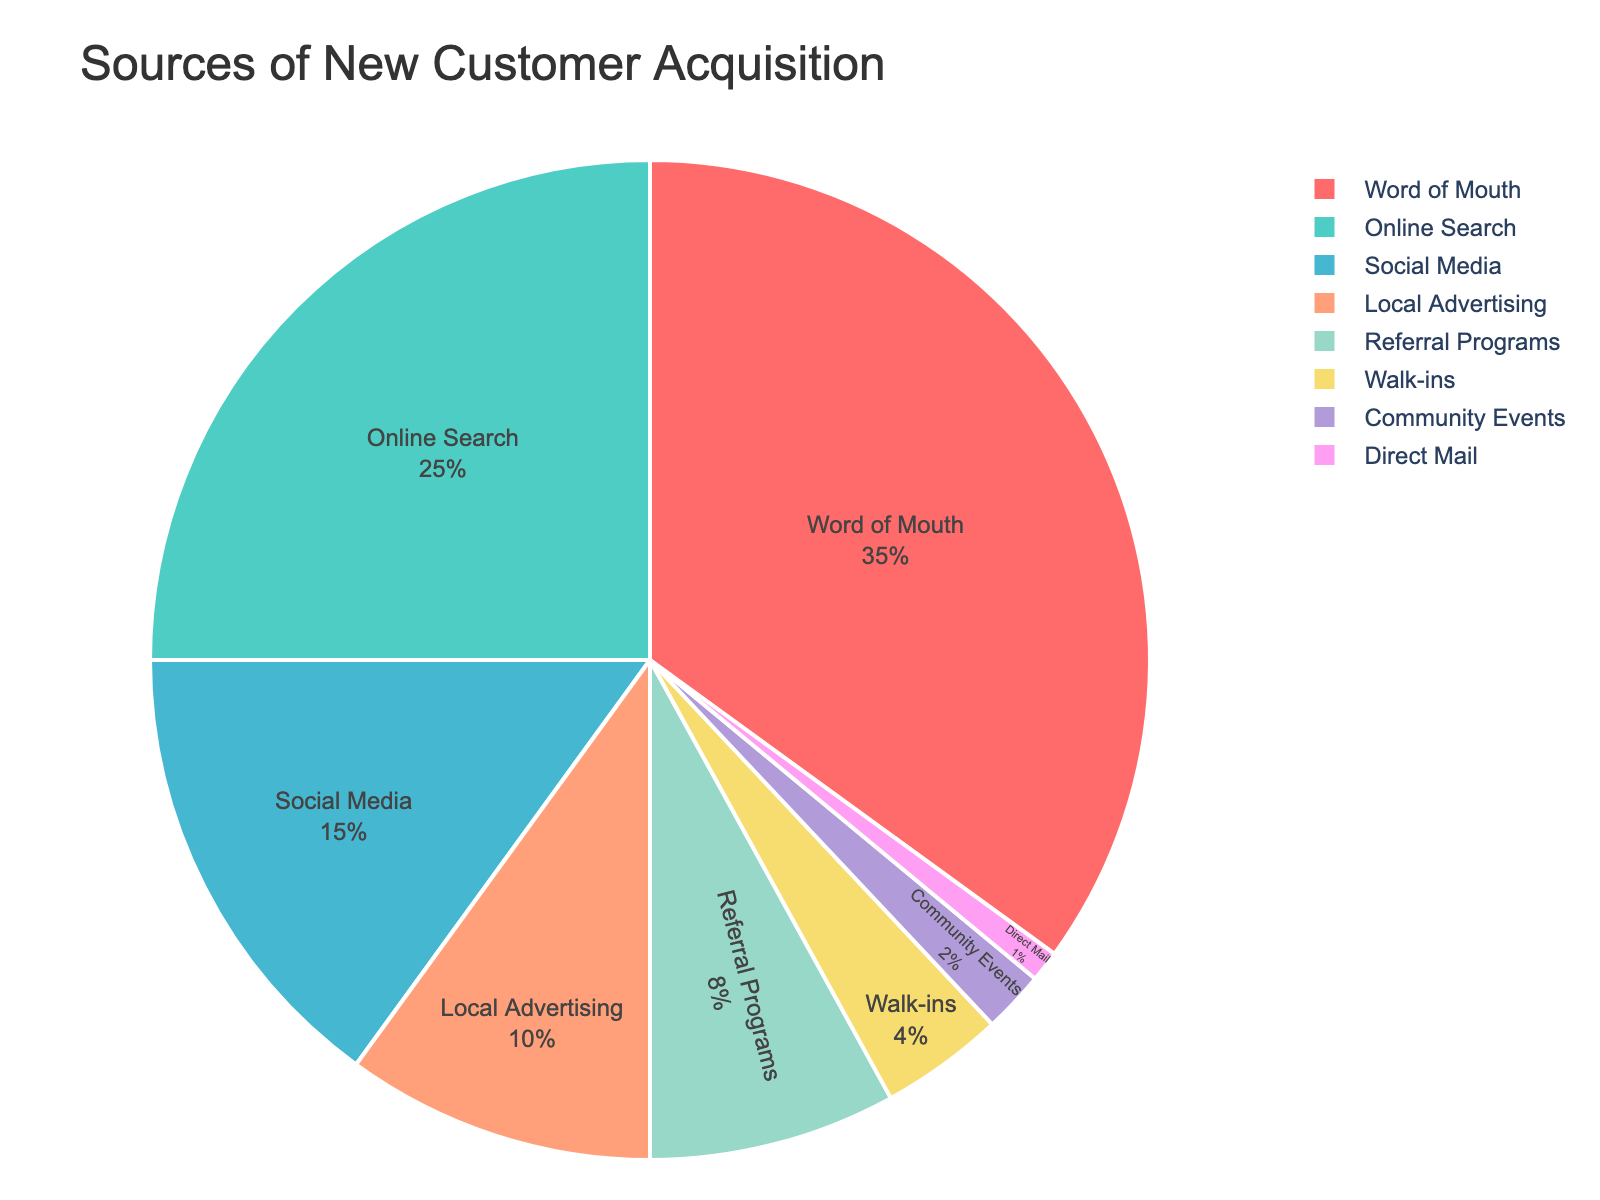What is the largest source of new customer acquisition? To find the largest source of new customer acquisition, look for the category with the highest percentage in the pie chart. The segment labeled "Word of Mouth" has the highest value at 35%.
Answer: Word of Mouth Which sources combined account for at least half of the new customer acquisitions? Add the percentages of the top categories until the sum is at least 50%. "Word of Mouth" is 35%, and "Online Search" is 25%. Their combined percentage is 35 + 25 = 60%, which is over half.
Answer: Word of Mouth and Online Search How much more effective is Social Media compared to Walk-ins? Find the percentage for both categories. "Social Media" has 15%, and "Walk-ins" has 4%. Subtract the smaller percentage from the larger one: 15% - 4% = 11%.
Answer: 11% What percentage of new customers come from Referral Programs and Community Events combined? Add the percentages for "Referral Programs" and "Community Events". Referral Programs are 8%, and Community Events are 2%. The total is 8 + 2 = 10%.
Answer: 10% Which categories have less than 5% contribution? Identify the segments with percentages under 5%. "Walk-ins" have 4%, "Community Events" have 2%, and "Direct Mail" has 1%.
Answer: Walk-ins, Community Events, and Direct Mail What is the second smallest source of new customer acquisition? Find the segment with the second lowest percentage. "Direct Mail" is the smallest at 1%, and the next smallest is "Community Events" at 2%.
Answer: Community Events What percentage more does Local Advertising contribute compared to Referral Programs? Find the percentages for both. Local Advertising is 10%, and Referral Programs are 8%. Subtract to find the difference: 10% - 8% = 2%.
Answer: 2% Which categories together provide exactly a quarter of the new customers? We're looking for categories that sum to 25%. "Social Media" alone contributes 15%. Adding "Walk-ins" (4%) and "Referral Programs" (8%) totals 27%, so we have to look for a different combination. However, we can use "Community Events" (2%) and "Direct Mail" (1%) together with "Social Media". This gives us 15 + 2 + 1 = 18%. The right combination is “Online Search”.
Answer: Online Search How many categories account for over 75% of new customer acquisitions together? Add the percentages of each segment starting from the highest until the sum exceeds 75%. "Word of Mouth" (35%) + "Online Search" (25%) + "Social Media" (15%) adds up to 75% exactly. Since we need over 75%, one more category is considered. Including "Local Advertising" (10%) adds up to 85%. This involves 3 categories.
Answer: 3 If you exclude Community Events and Direct Mail, what percentage do the remaining categories sum to? Subtract the percentages of "Community Events" (2%) and "Direct Mail" (1%) from 100%. Remaining categories account for 100% - (2% + 1%) = 97%.
Answer: 97% 